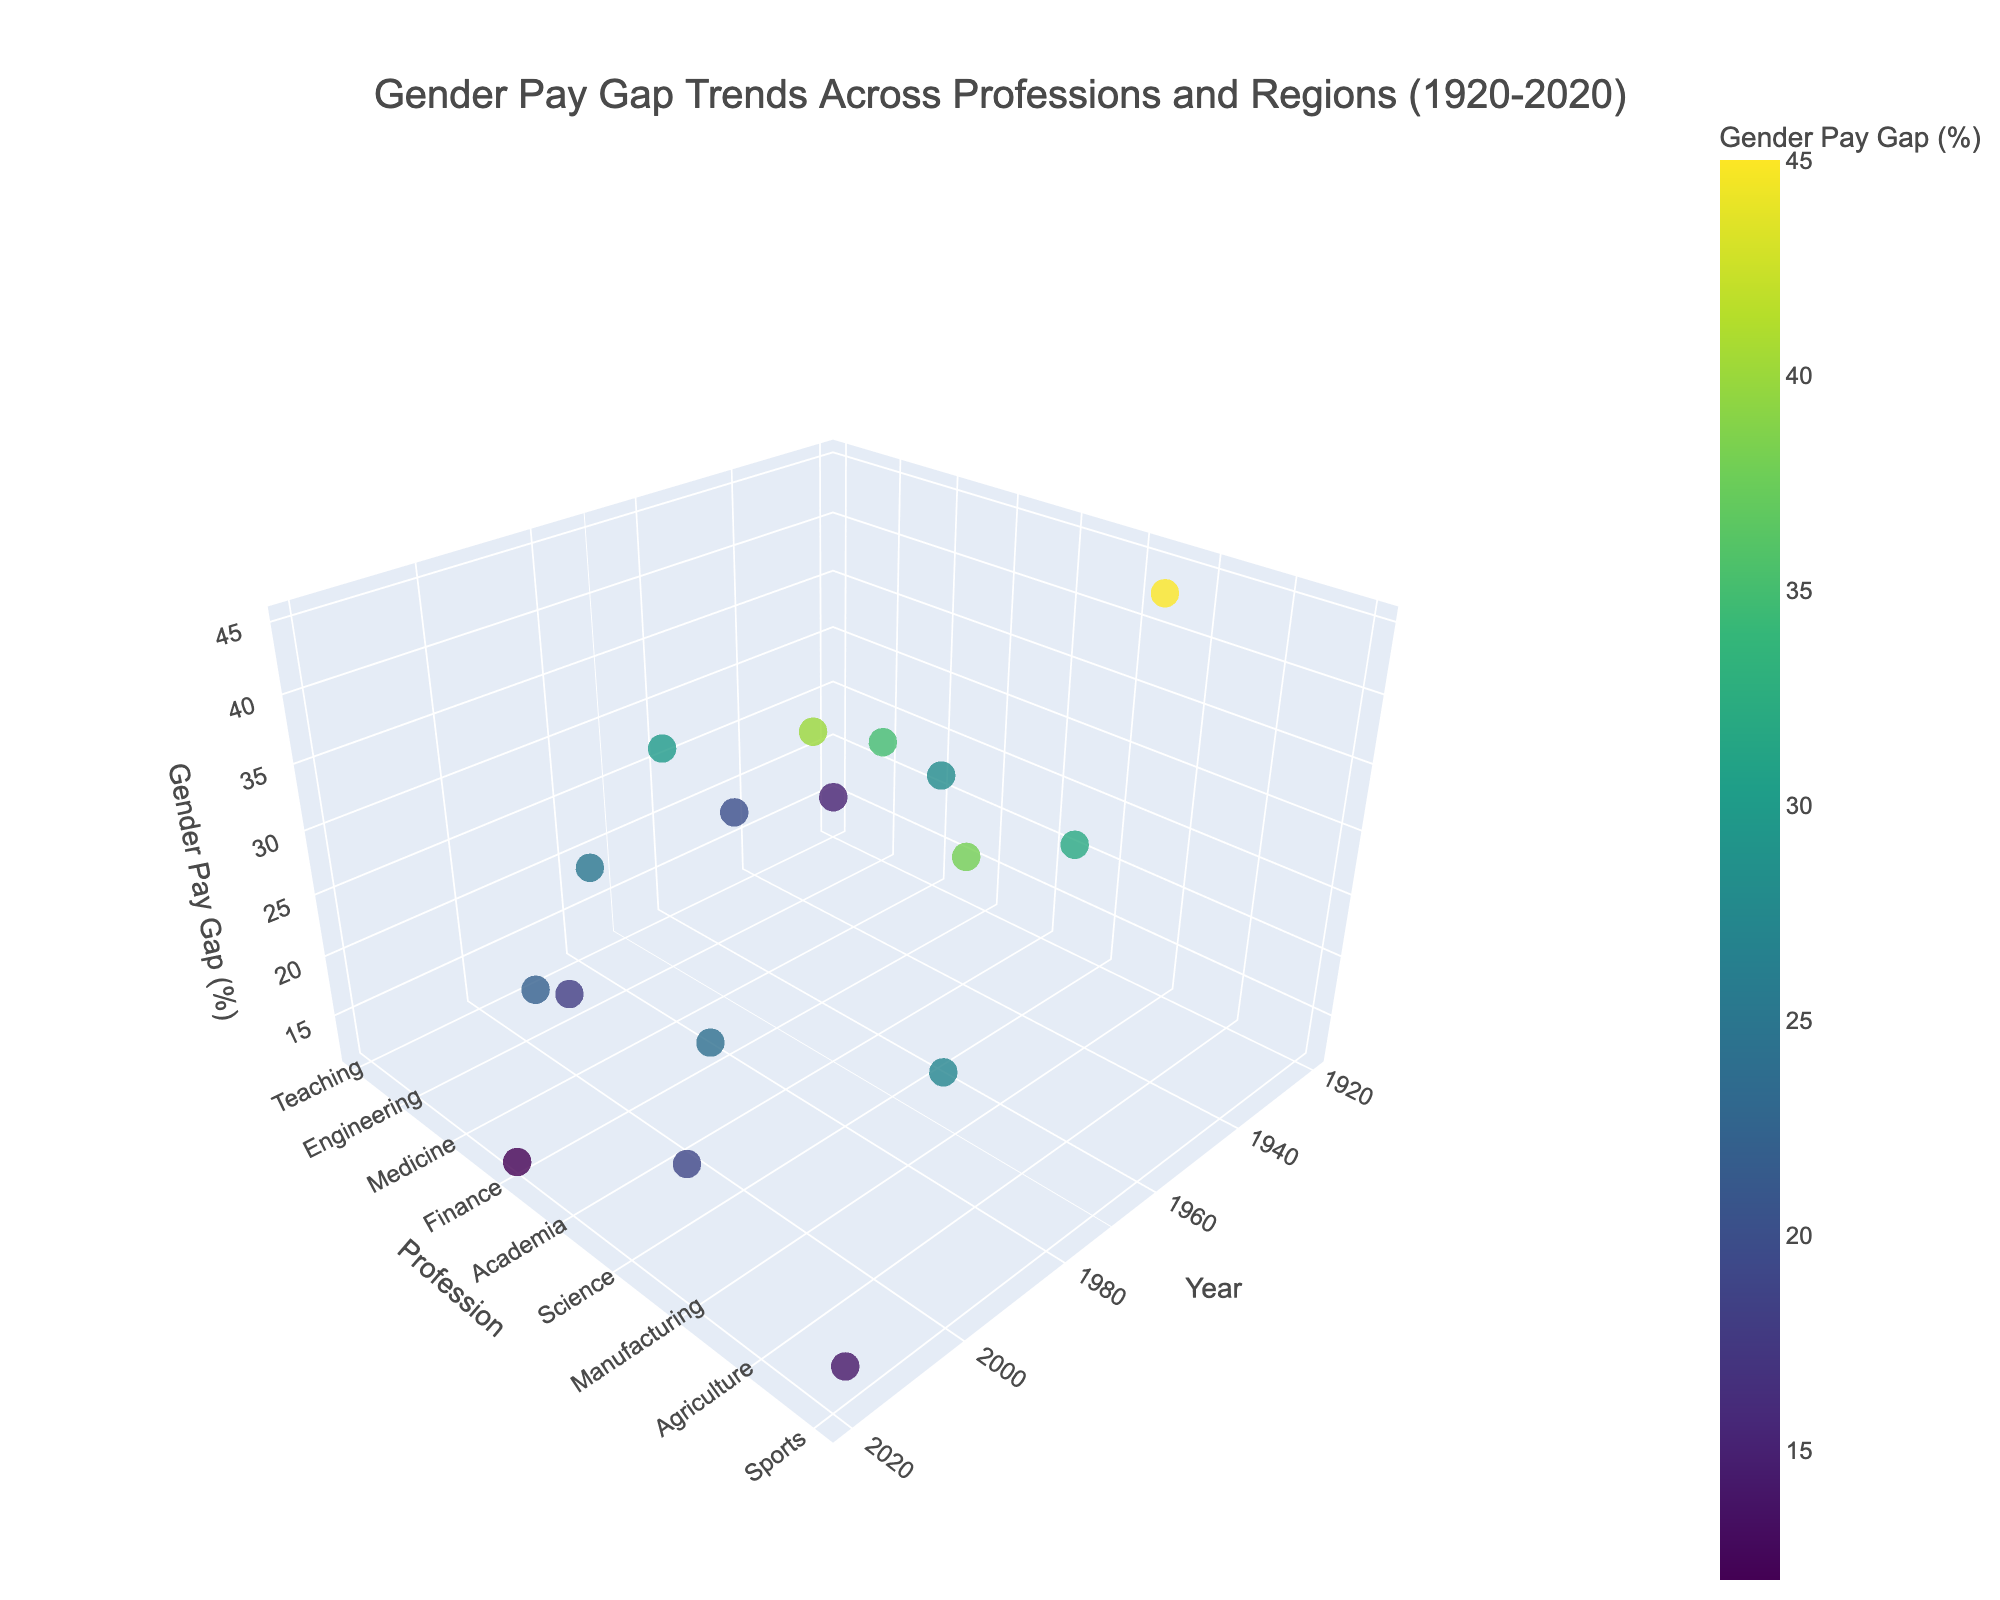What's the title of the figure? The title of the figure is usually displayed prominently at the top of the plot. In this case, the title reads "Gender Pay Gap Trends Across Professions and Regions (1920-2020)."
Answer: Gender Pay Gap Trends Across Professions and Regions (1920-2020) What do the colors on the markers represent? The colors on the markers represent the Gender Pay Gap (%) value. This is indicated by the colorbar on the plot, which correlates different colors to different gender pay gap percentages.
Answer: Gender Pay Gap (%) Which profession in this dataset has the highest gender pay gap and in what year? Reviewing the z-axis values and noting the highest marker position, the highest gender pay gap corresponds to "Manufacturing" in the "Soviet Union" in the year 1930, represented by the highest value on the gender pay gap axis (45%).
Answer: Manufacturing, 1930 How many years show a gender pay gap in the "Teaching" profession? Observing the year and profession axes for "Teaching", we see only one data point in the year 1920 with a pay gap value.
Answer: One year (1920) Which geographical regions are represented in the figure? The regions are listed in the text attribute for each data point, as displayed when hovered over. They include United States, United Kingdom, Germany, France, Canada, Japan, Australia, Sweden, Italy, Brazil, Soviet Union, Mexico, China, Spain, India, South Africa, and Norway.
Answer: United States, United Kingdom, Germany, France, Canada, Japan, Australia, Sweden, Italy, Brazil, Soviet Union, Mexico, China, Spain, India, South Africa, Norway What is the difference in the gender pay gap between "Nursing" in 1950 and "Finance" in 2020? The gender pay gap in the "Nursing" profession in 1950 (United Kingdom) is 20%, while in "Finance" in 2020 (Australia) it is 12%. The difference can be calculated as 20% - 12% = 8%.
Answer: 8% Which profession saw a gender pay gap under 20% in the year 2018? Looking at the 2018 data point, we find that "Sports" in Norway has a gender pay gap of 14%, which is under 20%.
Answer: Sports In what year did "Agriculture" see a gender pay gap, and what was the percentage? Although looking along the 'Profession' axis for "Agriculture" and checking the year, "Agriculture" in China shows a gender pay gap in the year 1985 with a value of 38%.
Answer: 1985, 38% How does the gender pay gap in "Technology" in 2010 compare to that in "Science" in 2005? "Technology" in Japan in 2010 has a gender pay gap of 22%, and "Science" in India in 2005 has a gender pay gap of 24%. Technology has a slightly lower gap compared to Science.
Answer: Technology (22%) < Science (24%) What is the average gender pay gap for the professions listed in the data for the 2000s decade (2000-2010)?. The professions listed in the 2000s are "Medicine" in 2000, "Science" in 2005, and "Technology" in 2010 with gaps of 18%, 24%, and 22%, respectively. The average is calculated as (18 + 24 + 22) / 3 = 21.33%.
Answer: 21.33% 